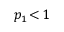<formula> <loc_0><loc_0><loc_500><loc_500>p _ { 1 } \, < \, 1</formula> 